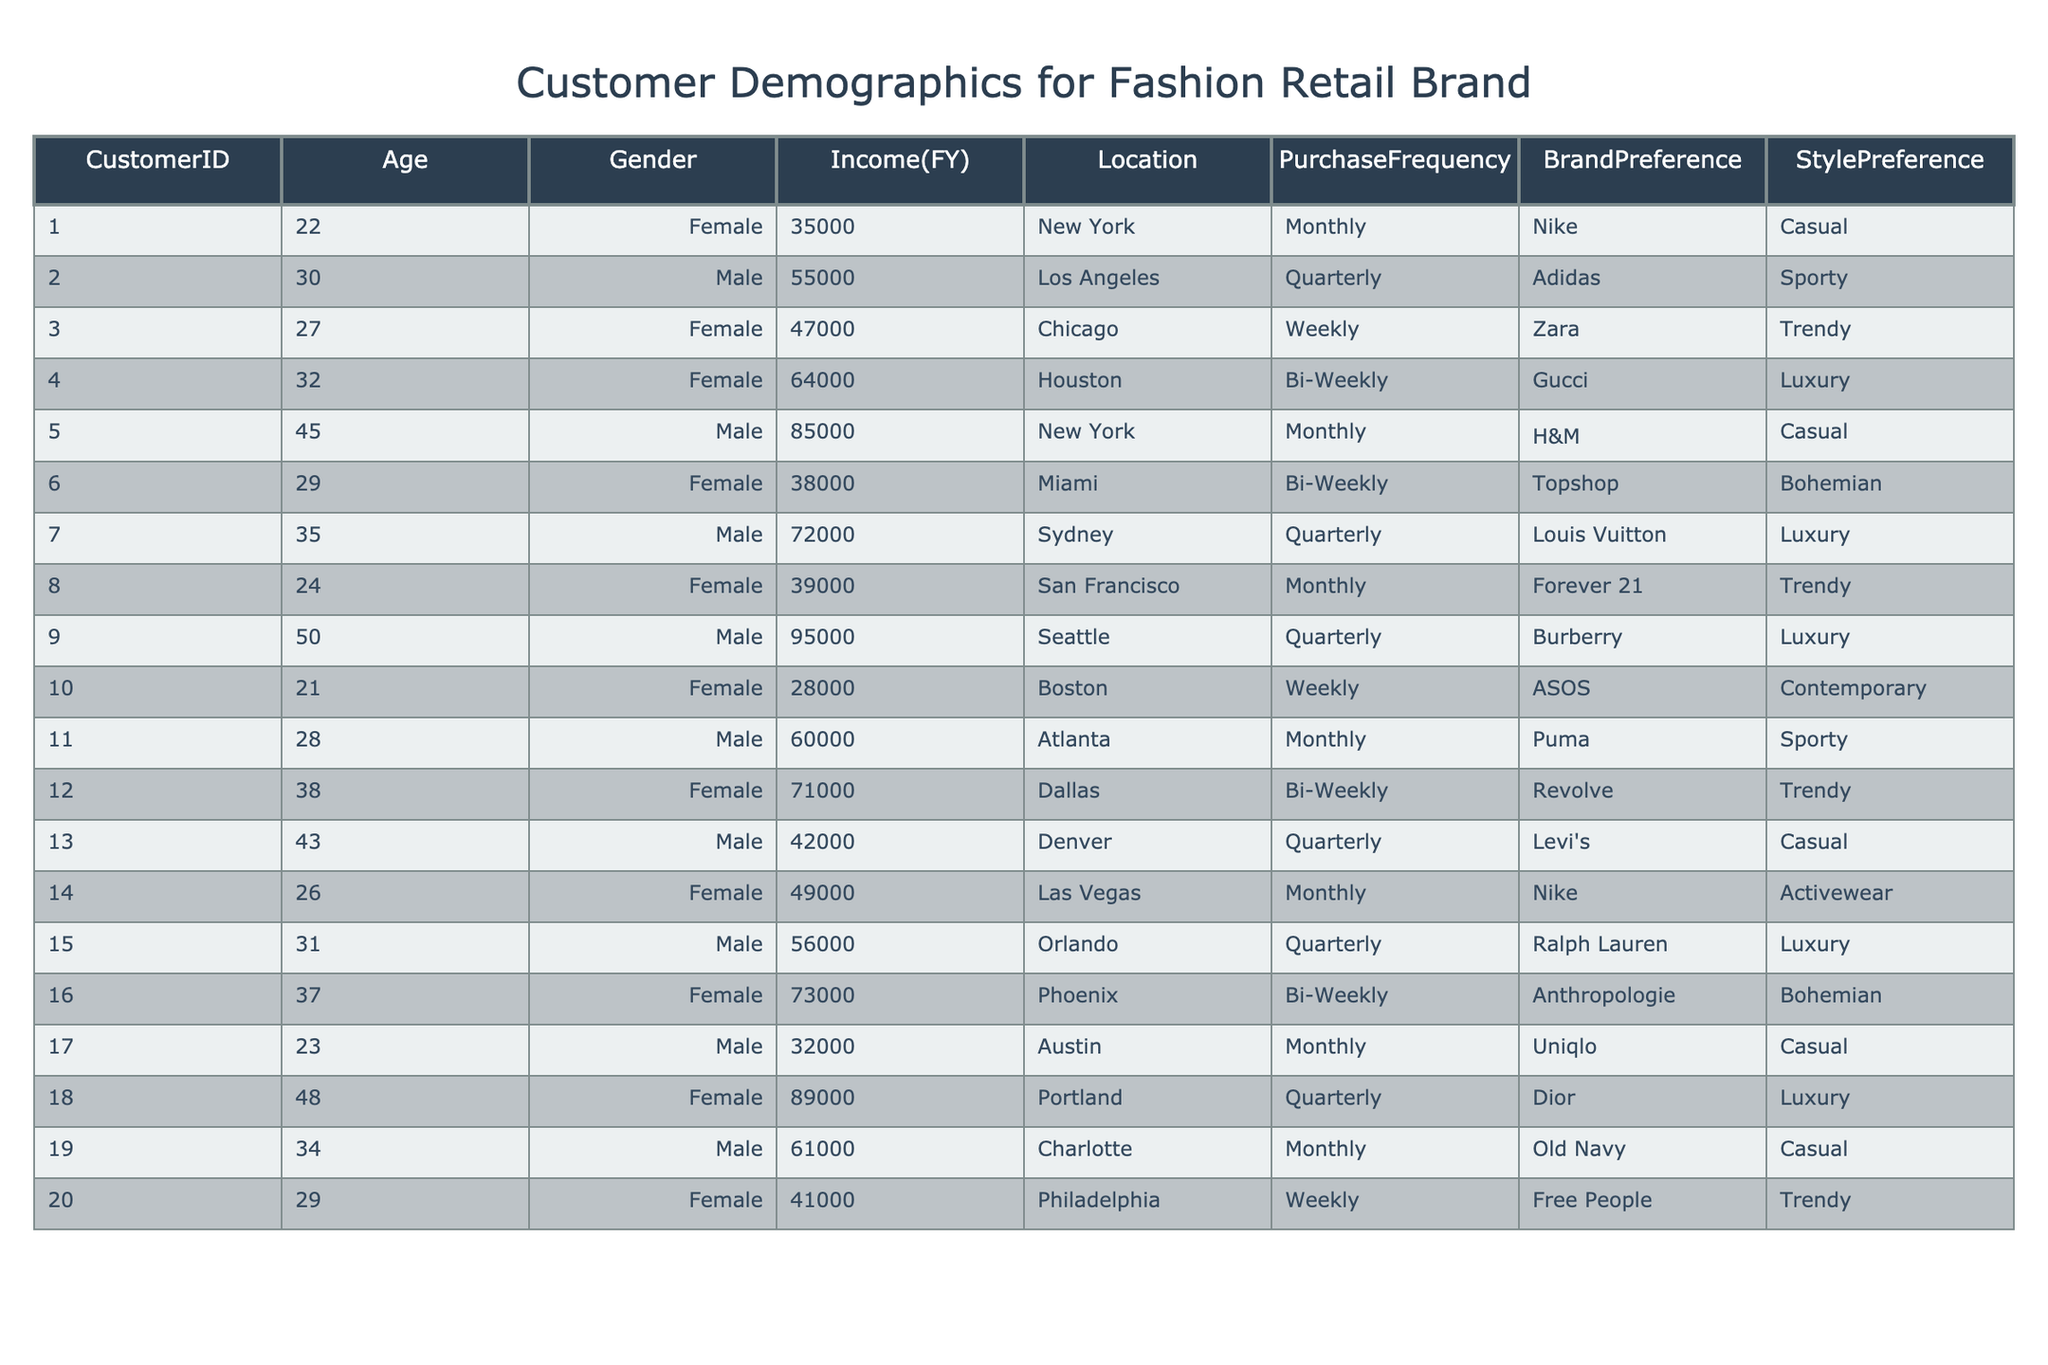What is the most common gender among customers? To determine the most common gender, I will count the occurrences of "Male" and "Female" in the Gender column. There are 10 Females (Customer IDs: 1, 3, 4, 6, 8, 10, 12, 14, 16, 18) and 10 Males (Customer IDs: 2, 5, 7, 9, 11, 13, 15, 17, 19, 20). Since both genders have the same count, there is no dominant gender.
Answer: Neither What age group has the highest average income? I will categorize the data into age groups and then calculate the average income for each group. The age groups are 20-29 (average income = 38233.33), 30-39 (average income = 63500), 40-49 (average income = 48250), and 50+ (average income = 95000). The highest average income is in the 50+ age group.
Answer: 50+ How many customers prefer luxury brands? To find out how many customers prefer luxury brands, I will filter the Brand Preference column for entries like Gucci, Louis Vuitton, Burberry, Dior, and Ralph Lauren. There are 6 customers who prefer luxury brands (Customer IDs: 4, 7, 9, 15, 18).
Answer: 6 What is the average income of Female customers? First, I will filter the customers based on the Gender column to identify Female customers. The income values for Females are 35000, 47000, 64000, 38000, 39000, 28000, 71000, 49000, 73000, 89000. Then, I will sum these values (35000 + 47000 + 64000 + 38000 + 39000 + 28000 + 71000 + 49000 + 73000 + 89000 = 385000) and divide by the number of Female customers (10) to obtain the average (385000/10 = 38500).
Answer: 38500 Are there any customers who have a Purchase Frequency of 'Weekly'? I will look for the Purchase Frequency column and check for any instances of "Weekly." There are 3 customers with a Purchase Frequency of "Weekly" (Customer IDs: 3, 10, 20). Thus, the answer is yes.
Answer: Yes 